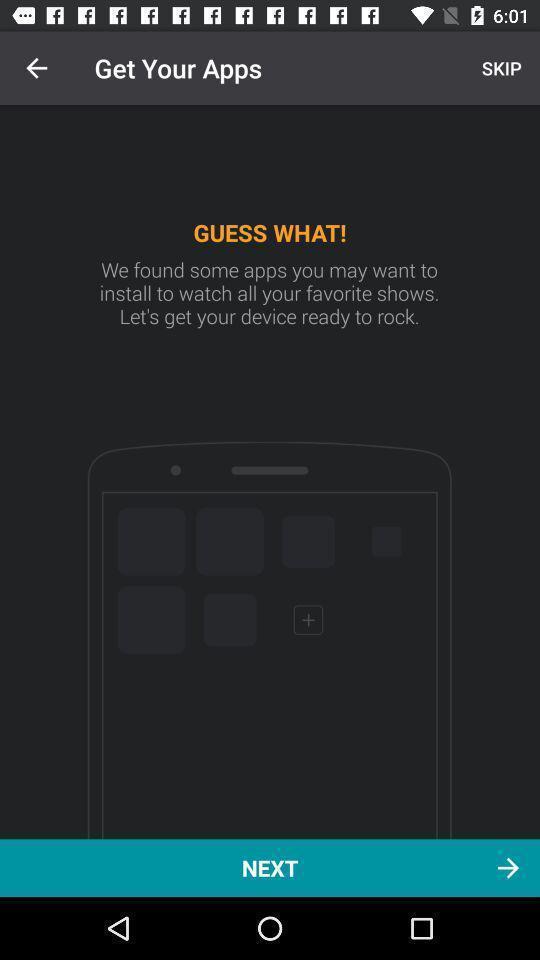Summarize the information in this screenshot. Welcome page. 